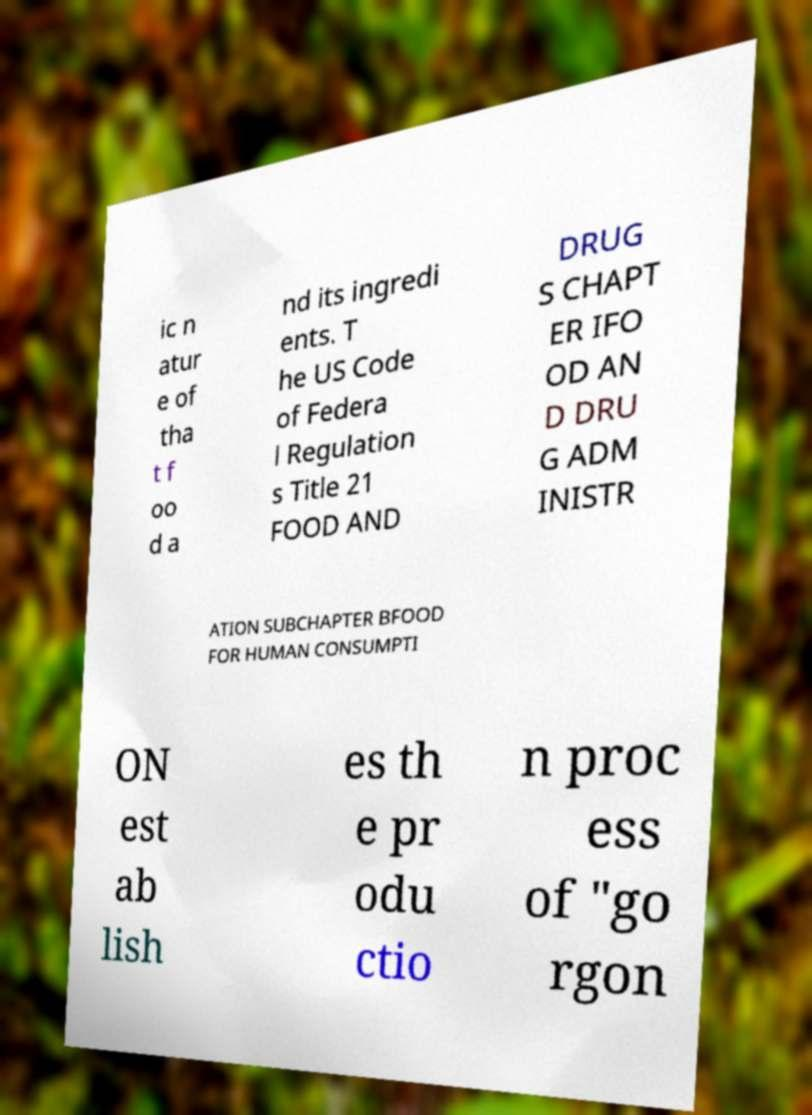Could you extract and type out the text from this image? ic n atur e of tha t f oo d a nd its ingredi ents. T he US Code of Federa l Regulation s Title 21 FOOD AND DRUG S CHAPT ER IFO OD AN D DRU G ADM INISTR ATION SUBCHAPTER BFOOD FOR HUMAN CONSUMPTI ON est ab lish es th e pr odu ctio n proc ess of "go rgon 